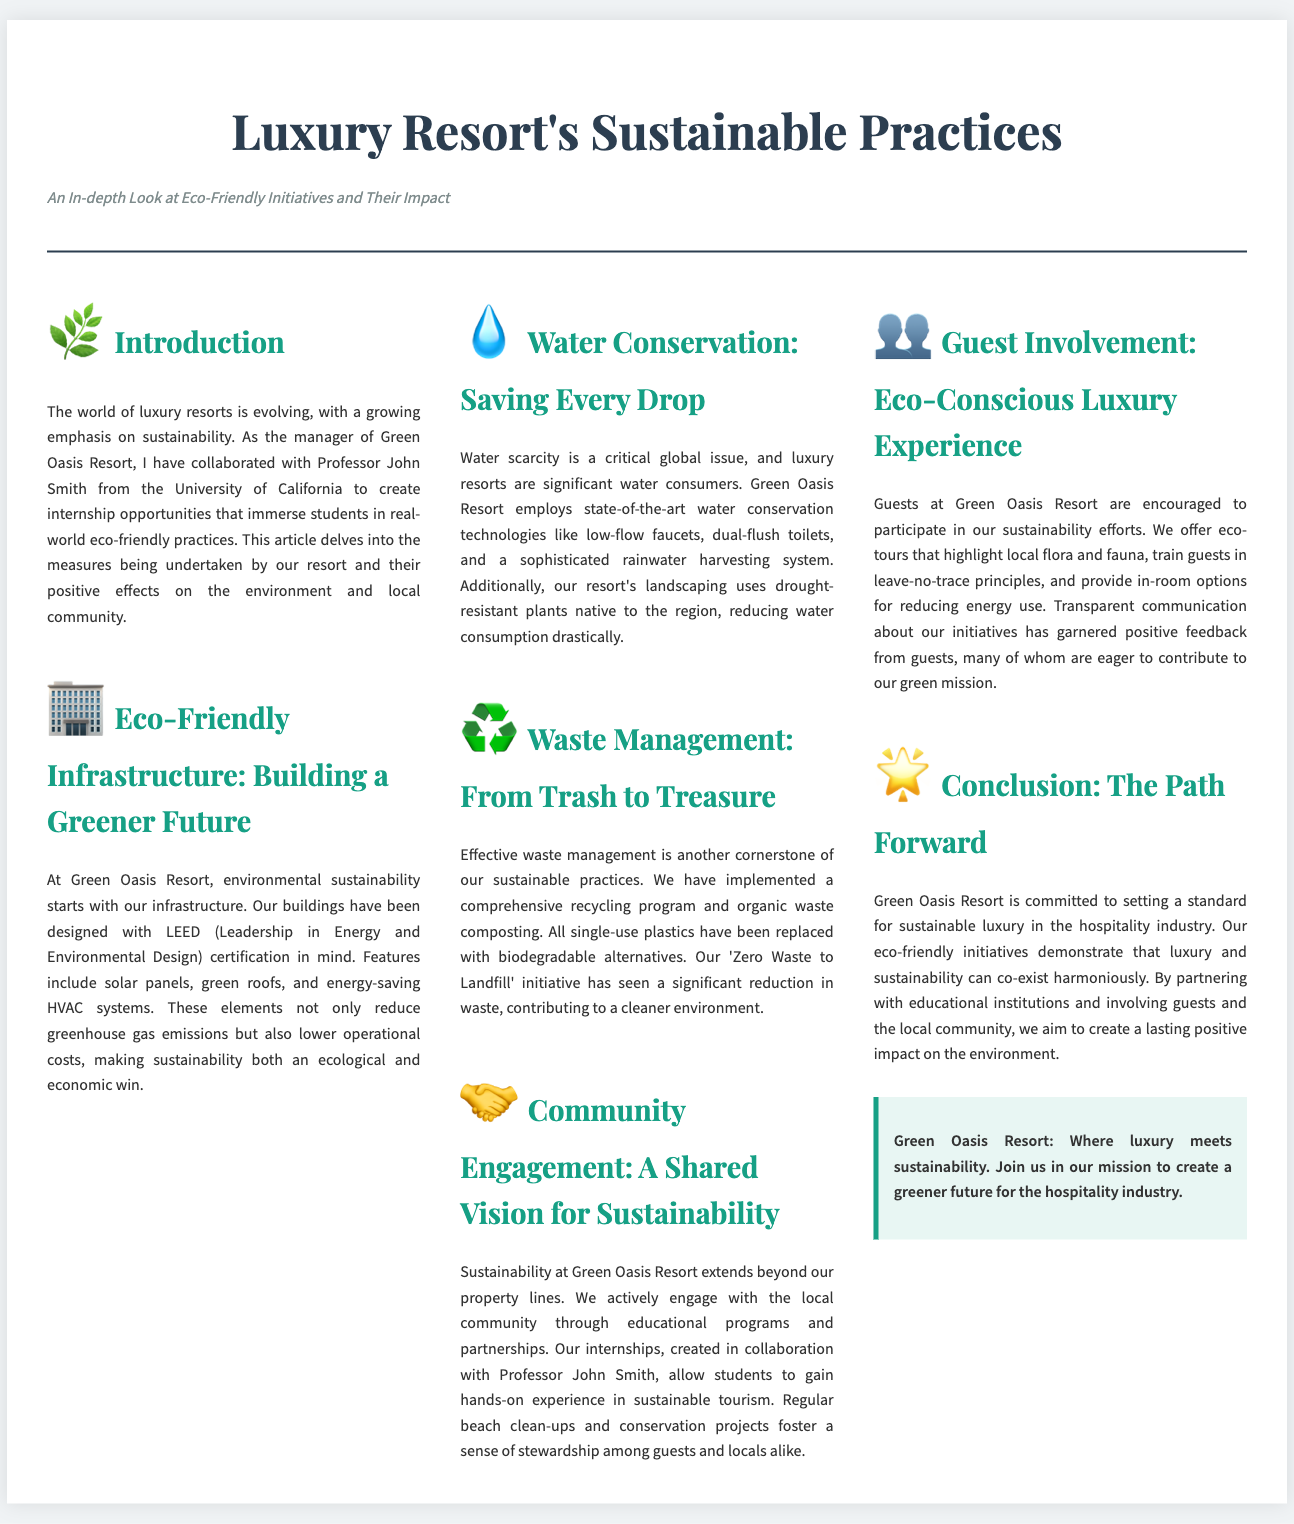What is the name of the resort? The name of the resort discussed in the document is Green Oasis Resort.
Answer: Green Oasis Resort Who collaborated with the manager to create internship opportunities? The professor mentioned in the document who collaborated with the manager is John Smith.
Answer: John Smith What certification does the resort's infrastructure have? The document states that the resort's infrastructure is designed with LEED certification in mind.
Answer: LEED What type of plants are used in the resort's landscaping? The landscaping at the resort uses drought-resistant plants native to the region.
Answer: Drought-resistant What is the goal of the 'Zero Waste to Landfill' initiative? The aim of the 'Zero Waste to Landfill' initiative is to significantly reduce waste at the resort.
Answer: Reduce waste How does the resort promote community engagement? The resort promotes community engagement through educational programs and partnerships.
Answer: Educational programs What feature do guests participate in to enhance sustainability? Guests are encouraged to participate in eco-tours that highlight local flora and fauna.
Answer: Eco-tours What is a key commitment of the Green Oasis Resort? The key commitment of Green Oasis Resort is to set a standard for sustainable luxury in the hospitality industry.
Answer: Sustainable luxury 